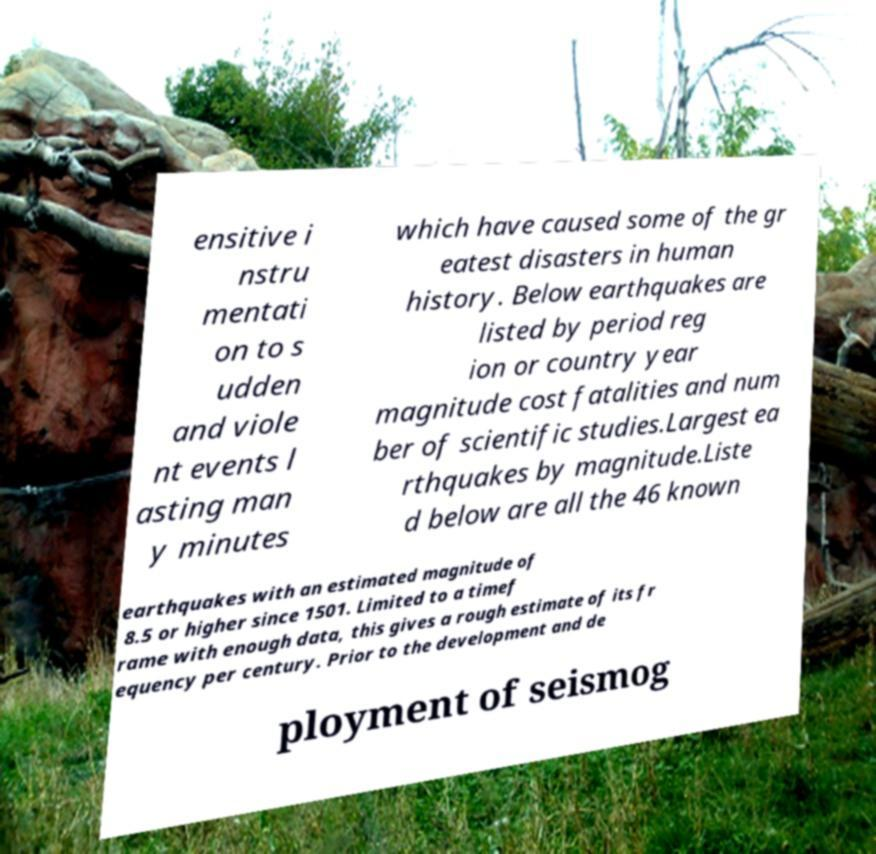Please identify and transcribe the text found in this image. ensitive i nstru mentati on to s udden and viole nt events l asting man y minutes which have caused some of the gr eatest disasters in human history. Below earthquakes are listed by period reg ion or country year magnitude cost fatalities and num ber of scientific studies.Largest ea rthquakes by magnitude.Liste d below are all the 46 known earthquakes with an estimated magnitude of 8.5 or higher since 1501. Limited to a timef rame with enough data, this gives a rough estimate of its fr equency per century. Prior to the development and de ployment of seismog 